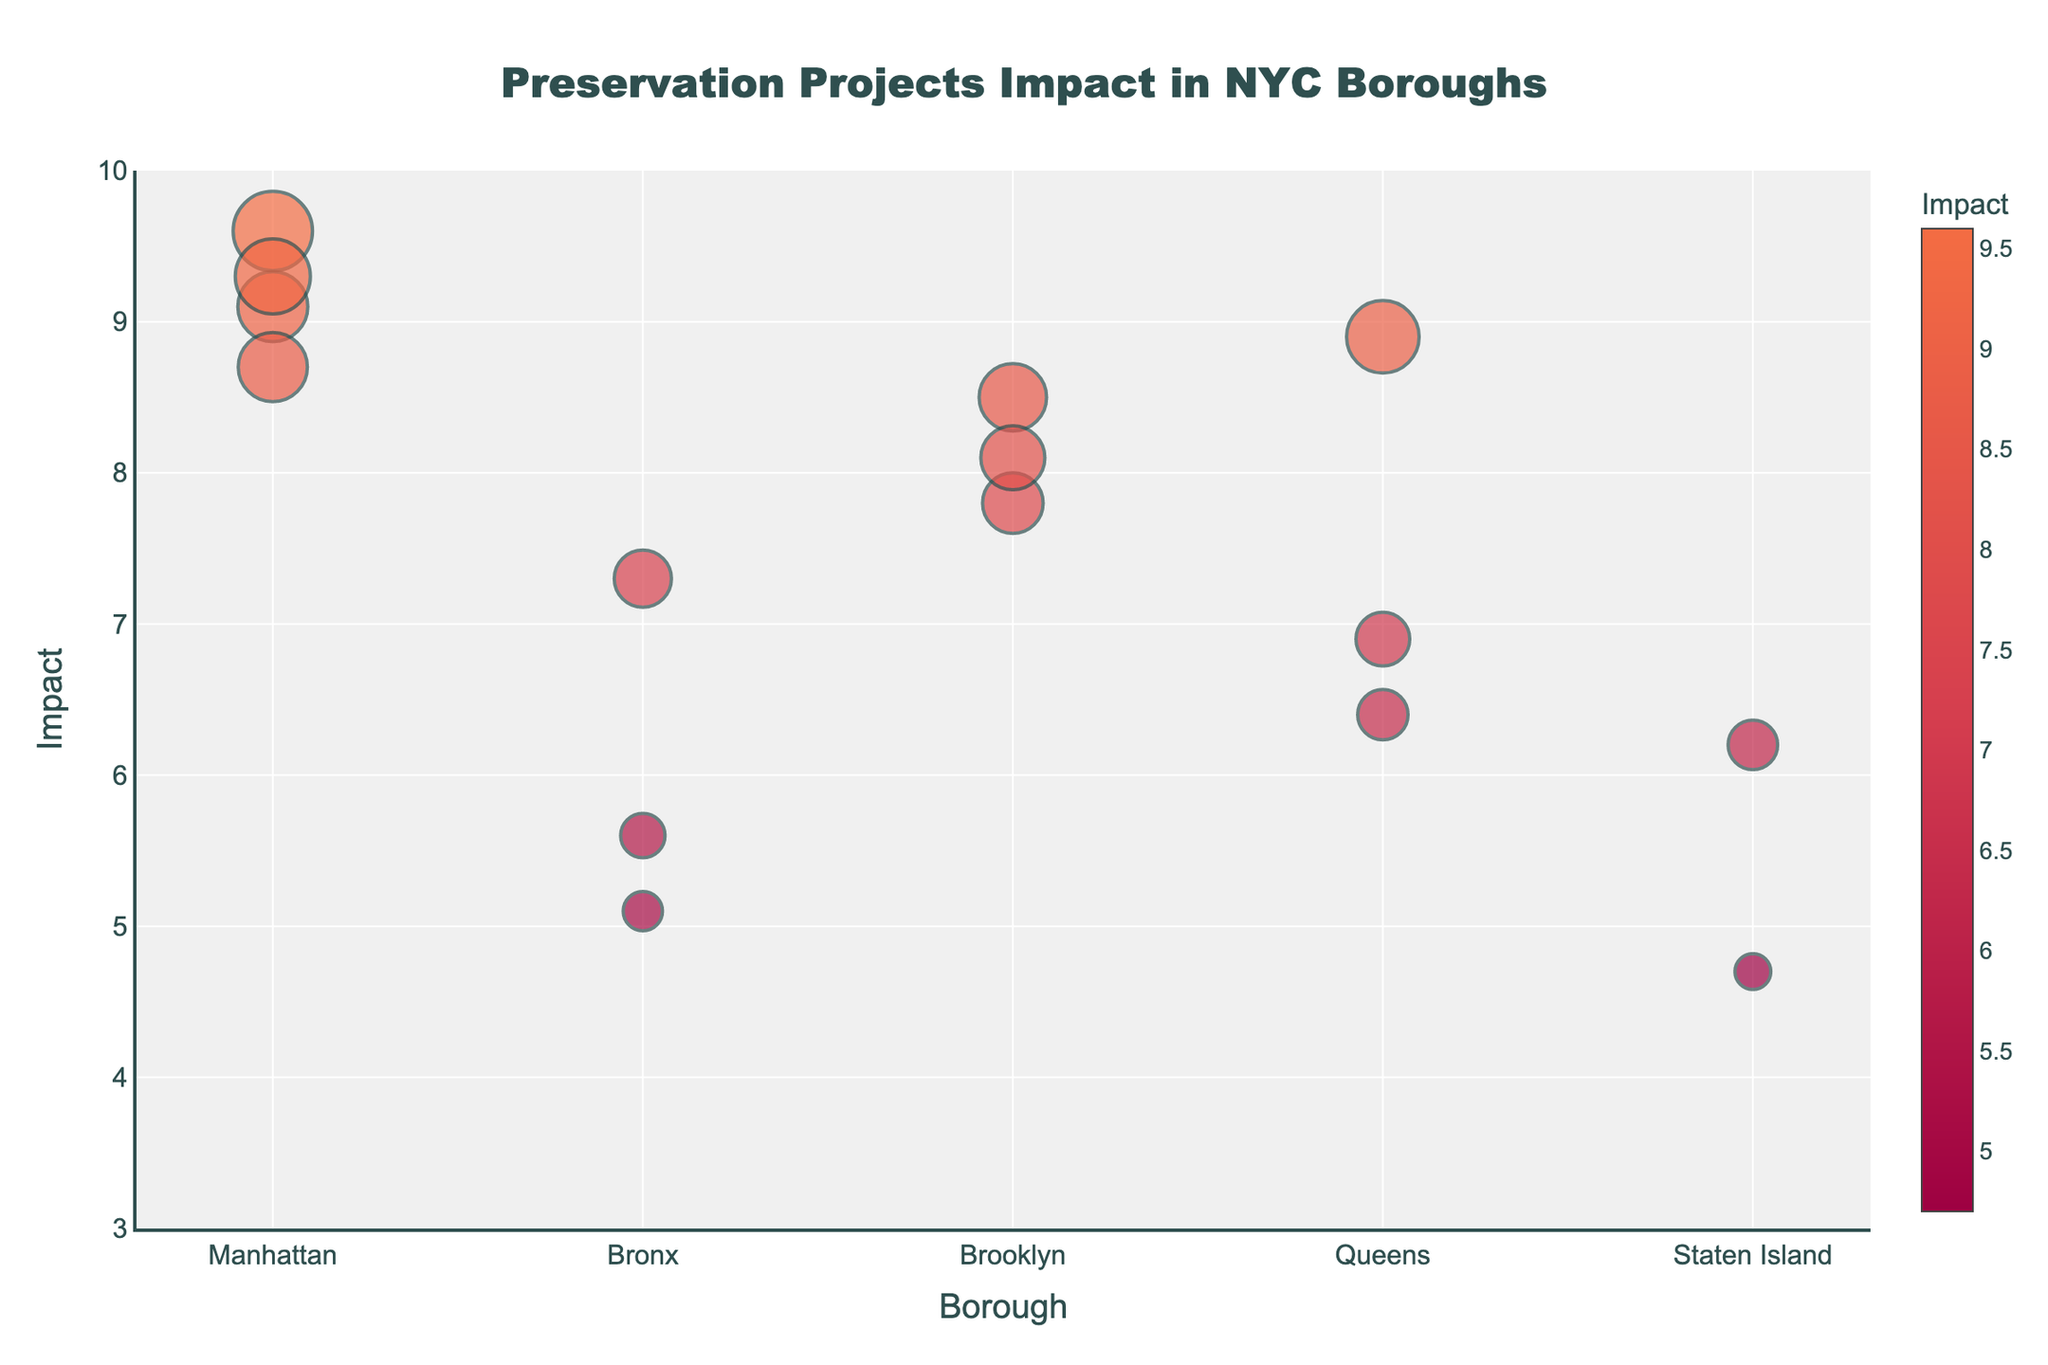How many preservation projects are shown in the figure across all boroughs? Count the number of data points (markers) on the plot representing the projects.
Answer: 15 Which borough has the project with the highest impact? Look at the y-axis values and identify the project with the highest y-value, then check which borough it belongs to.
Answer: Manhattan What is the average significance of the projects in Brooklyn? Identify all Brooklyn projects, sum their significance values, and divide by the number of Brooklyn projects.
Answer: 7.5 Which project has the largest marker size? Examine the size of all the markers; the largest one corresponds to the highest significance value. Find the project that has this marker size.
Answer: High Line Park Development Compare the impact values of the projects in Manhattan and Brooklyn. Which borough, on average, has a higher impact? Calculate the average impact for projects in Manhattan and Brooklyn separately, then compare these averages.
Answer: Manhattan Is there a borough with no projects having an impact value below 5? Check each borough's projects and see if any project within has an impact value below 5.
Answer: Yes, Manhattan and Brooklyn What is the approximate average impact value for the projects in Staten Island? Sum the impact values of Staten Island projects and divide by the number of projects in Staten Island.
Answer: 5.45 